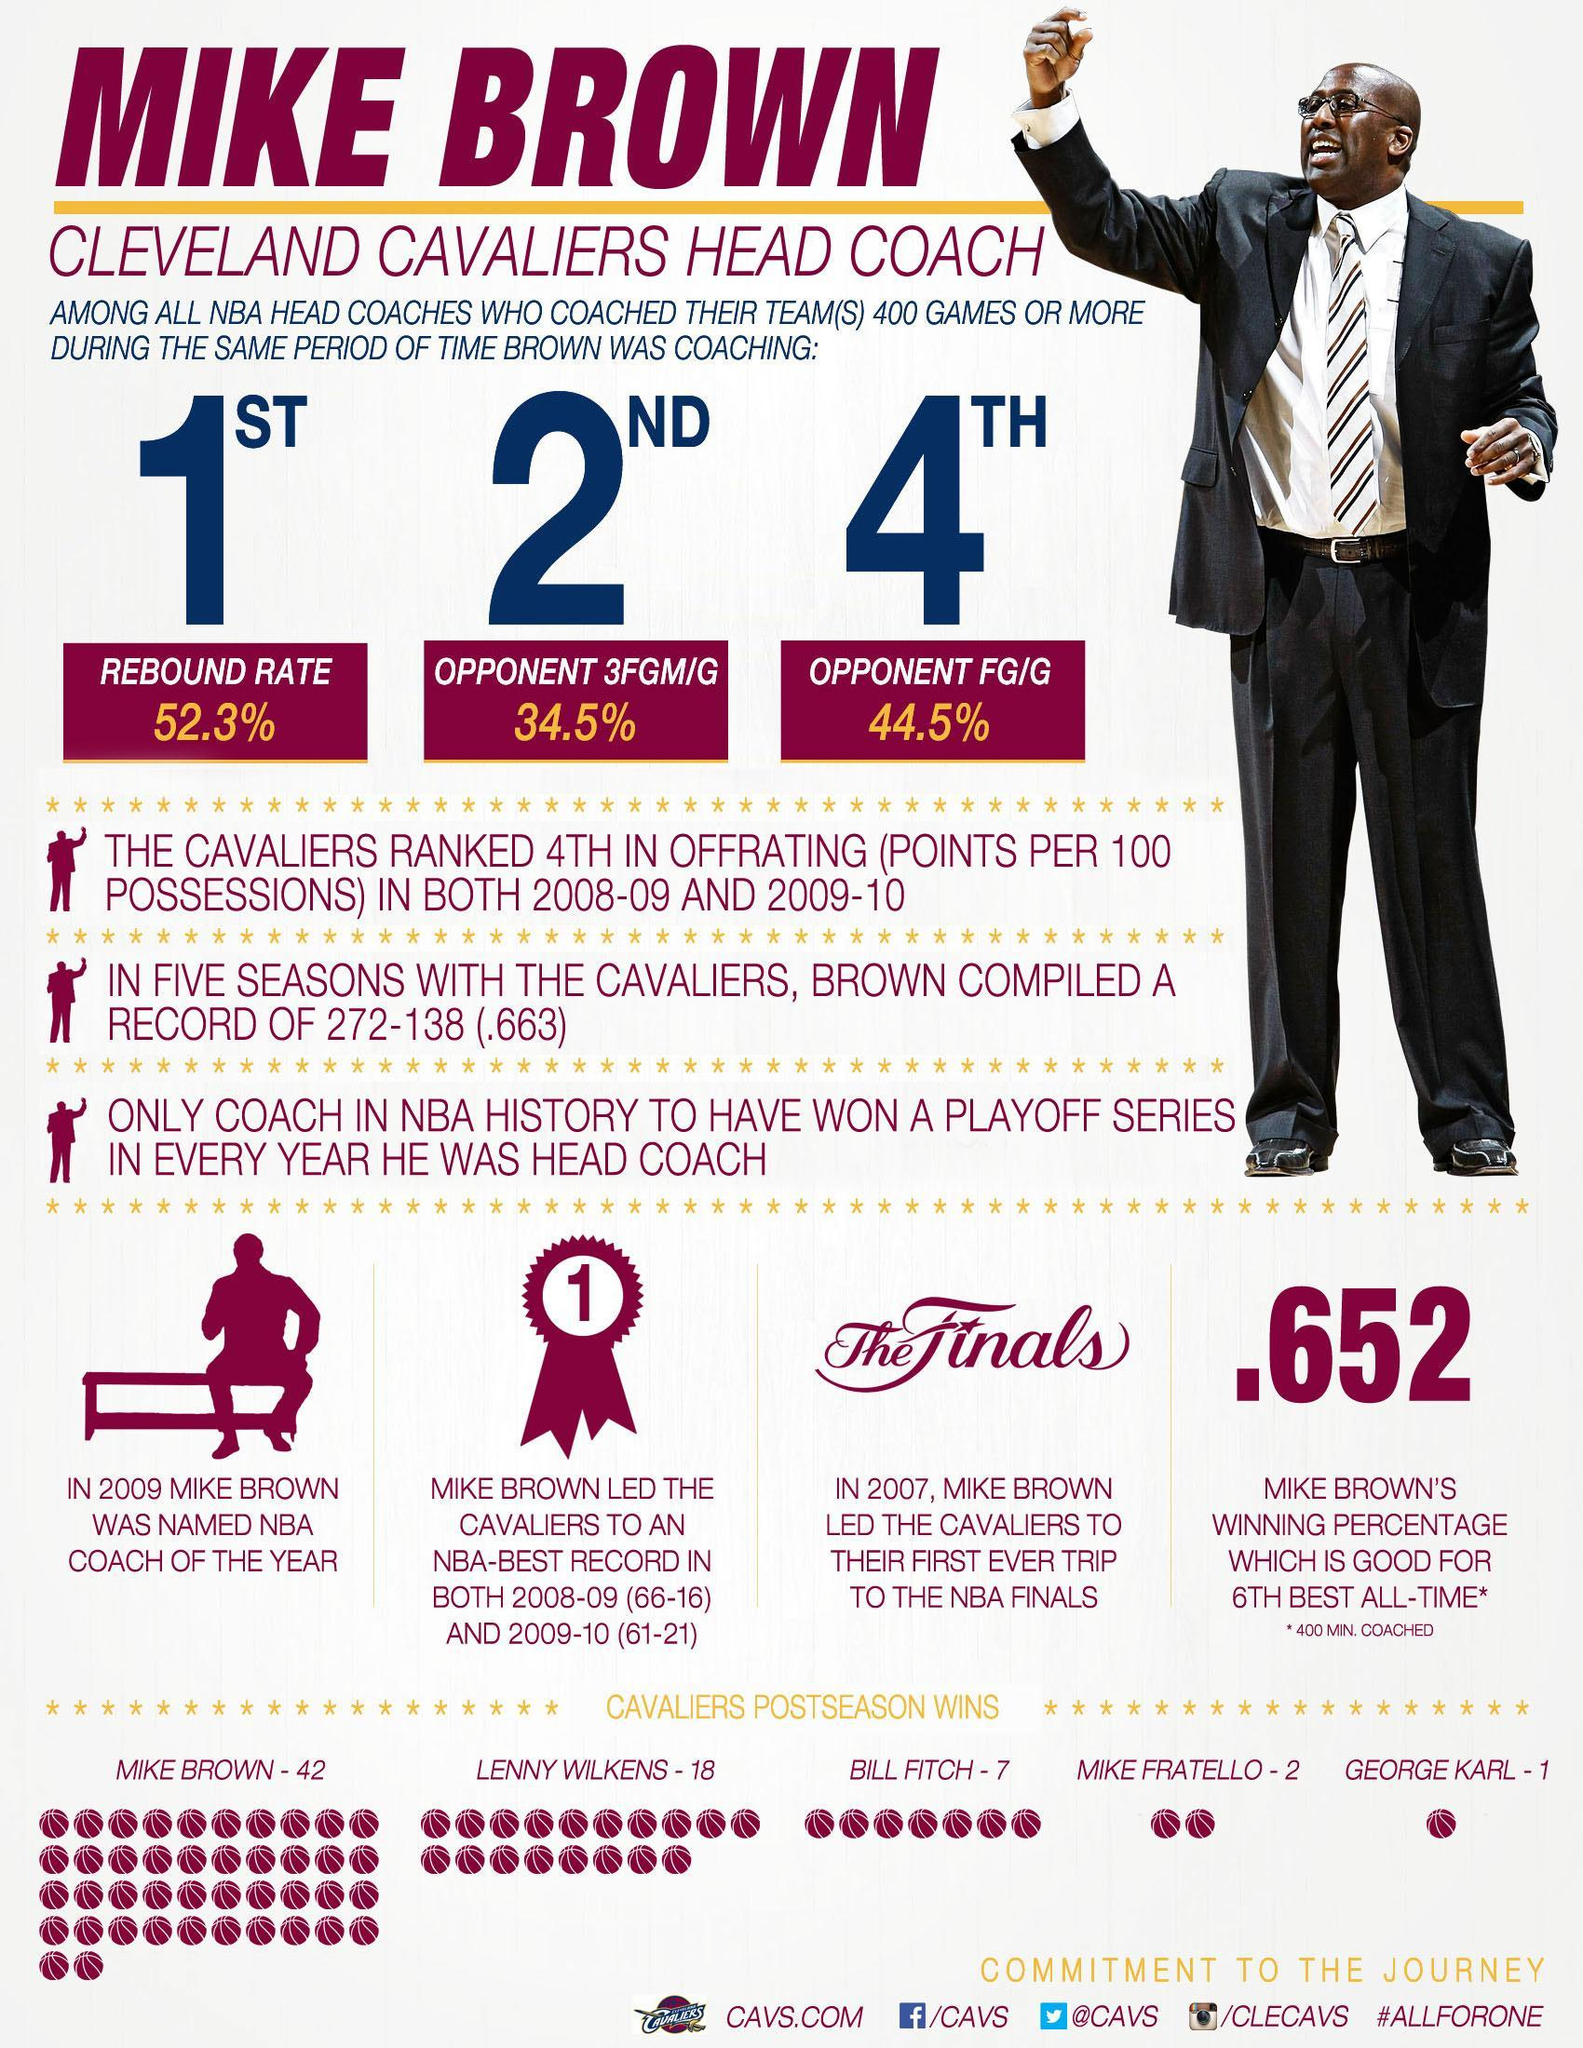In which year did Mike Brown led the Cavaliers to their first ever NBA finals?
Answer the question with a short phrase. 2007 In which year was Mike Brown named as the NBA coach of the year? 2009 